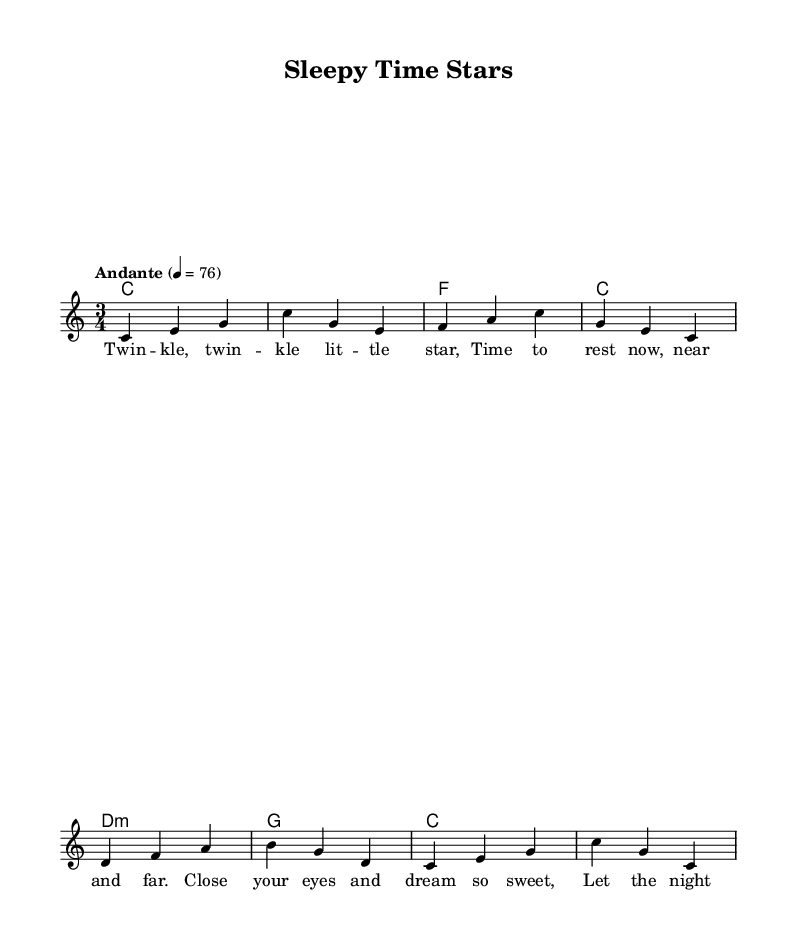What is the key signature of this music? The key signature is indicated by the presence of no sharps or flats at the beginning of the staff, which identifies it as C major.
Answer: C major What is the time signature of this music? The time signature is represented by the numbers at the beginning of the staff, showing that there are three beats per measure.
Answer: 3/4 What is the tempo marking for this piece? The tempo marking appears in text after the time signature and indicates a moderate speed of 76 beats per minute.
Answer: Andante 4 = 76 How many measures are in the melody? By counting the measure bar lines in the melody section, we see there are eight distinct measures.
Answer: 8 What style is this piece classified as? The style classification is usually indicated by the title and content; in this case, it is noted to be a folk lullaby intended for soothing and bedtime routines.
Answer: Folk What is the first lyric of the piece? The first lyric is the opening line written under the corresponding notes in the melody, which is "Twinkle, twinkle little star."
Answer: Twinkle, twinkle little star Which harmony corresponds to the first measure? The harmony part begins with a chord indicated in the chord mode section that matches the melody, which is the C major chord for the first measure.
Answer: C 